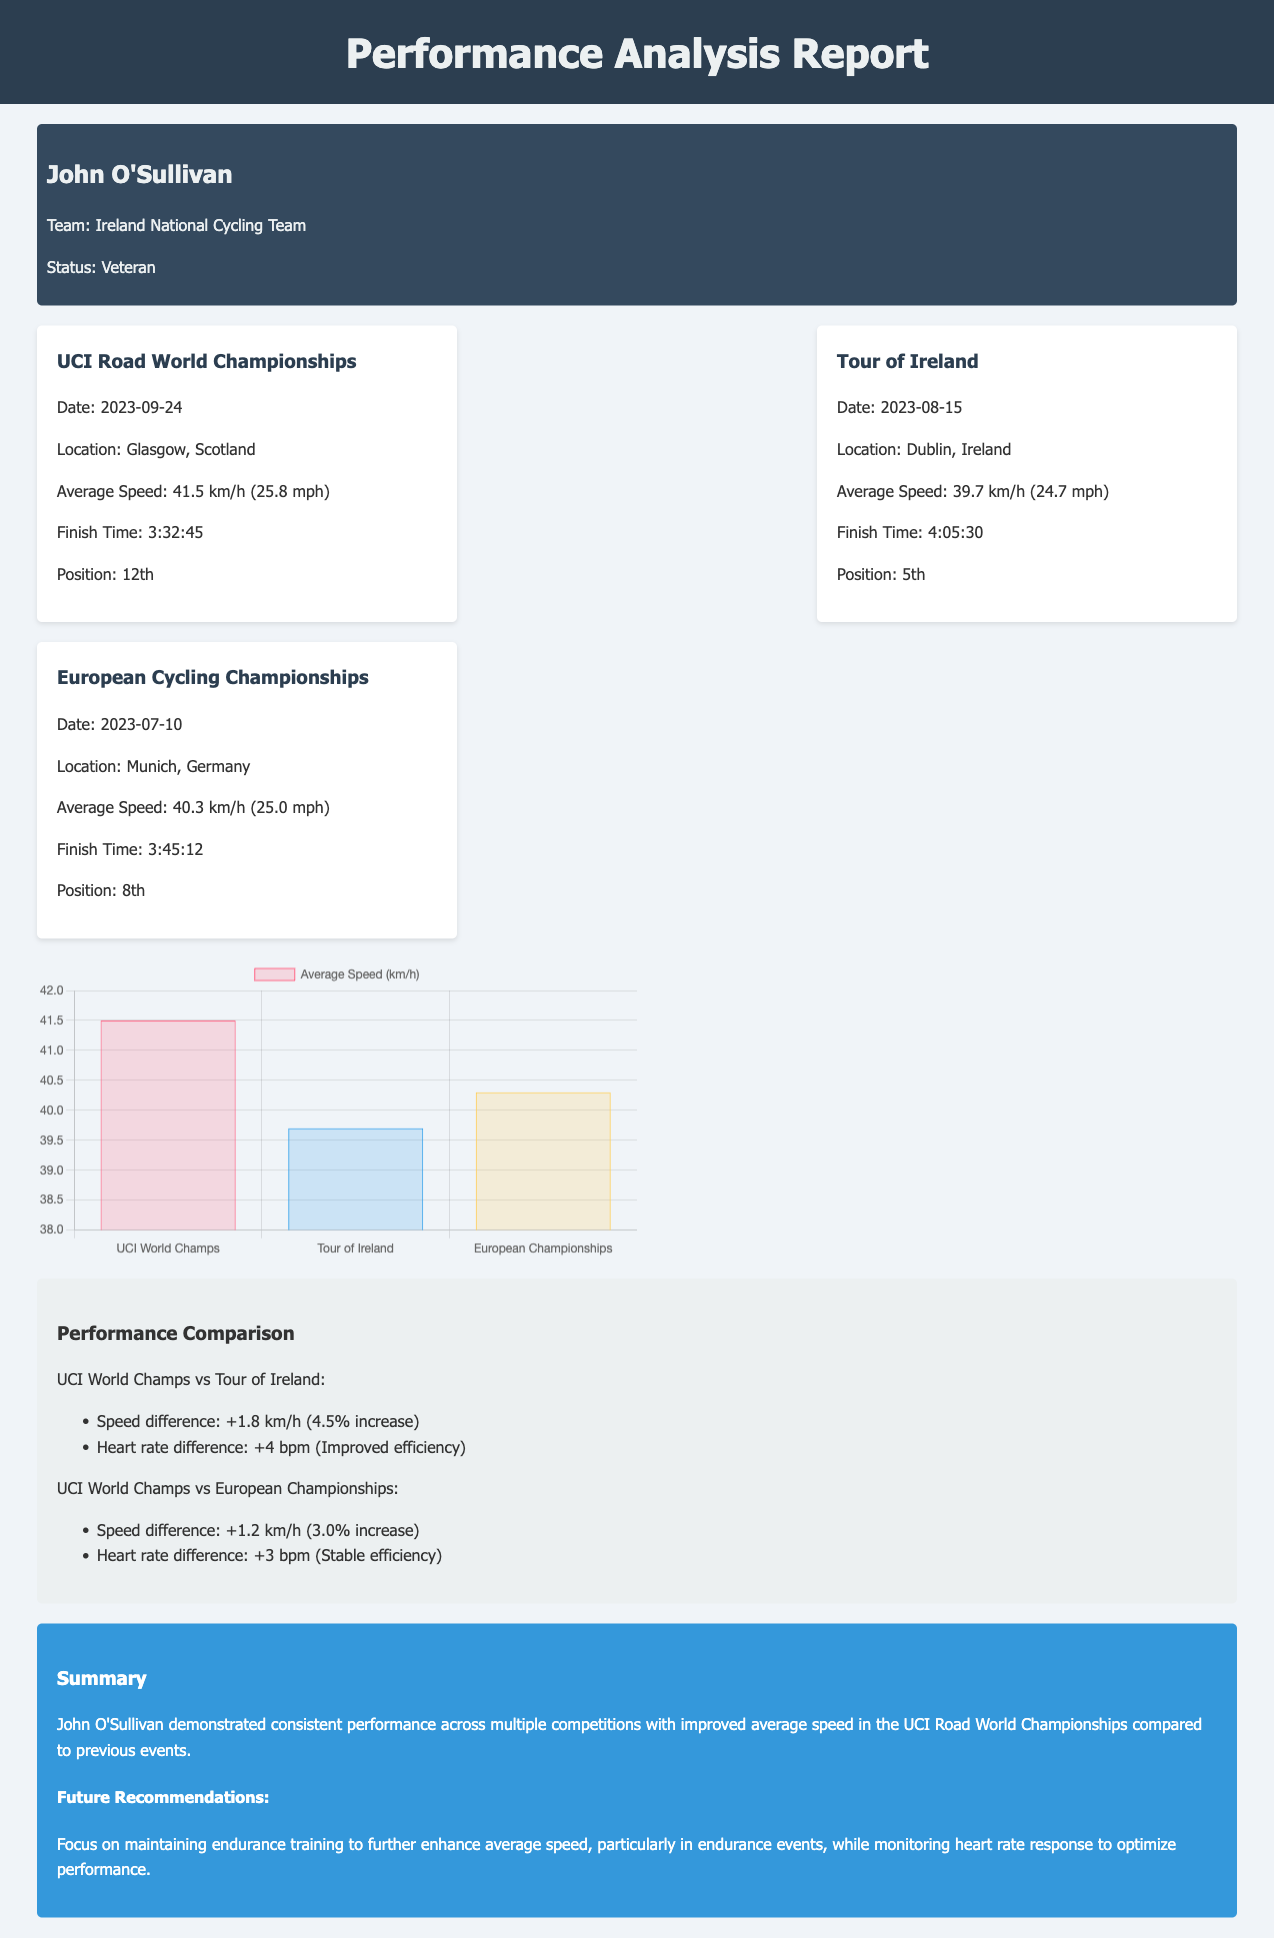What is the athlete's name? The athlete's name is mentioned in the document header.
Answer: John O'Sullivan What was the average speed in the UCI Road World Championships? The average speed for this race is specified in the race results section.
Answer: 41.5 km/h What position did John O'Sullivan finish in the Tour of Ireland? The final position for this race is provided in the race card.
Answer: 5th What were the heart rate differences in the UCI World Champs compared to the Tour of Ireland? This information is included in the performance comparison section.
Answer: +4 bpm What is the recommended focus for future training? Recommendations for future training can be found in the summary section.
Answer: Endurance training What date did the European Cycling Championships take place? The date of this event is listed in the race results section.
Answer: 2023-07-10 How many competitions are included in the performance analysis? The number of races is indicated by the number of race cards shown in the document.
Answer: 3 What was John O'Sullivan's finish time for the European Cycling Championships? The finish time is defined within the race card for that event.
Answer: 3:45:12 What is emphasized in the performance comparison with the European Championships? The performance comparison section highlights specific performance metrics.
Answer: Stable efficiency 